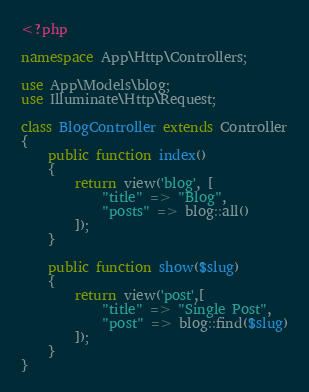<code> <loc_0><loc_0><loc_500><loc_500><_PHP_><?php

namespace App\Http\Controllers;

use App\Models\blog;
use Illuminate\Http\Request;

class BlogController extends Controller
{
    public function index()
    {
        return view('blog', [
            "title" => "Blog",
            "posts" => blog::all()
        ]);
    }

    public function show($slug)
    {
        return view('post',[
            "title" => "Single Post",
            "post" => blog::find($slug)
        ]);
    }
}
</code> 